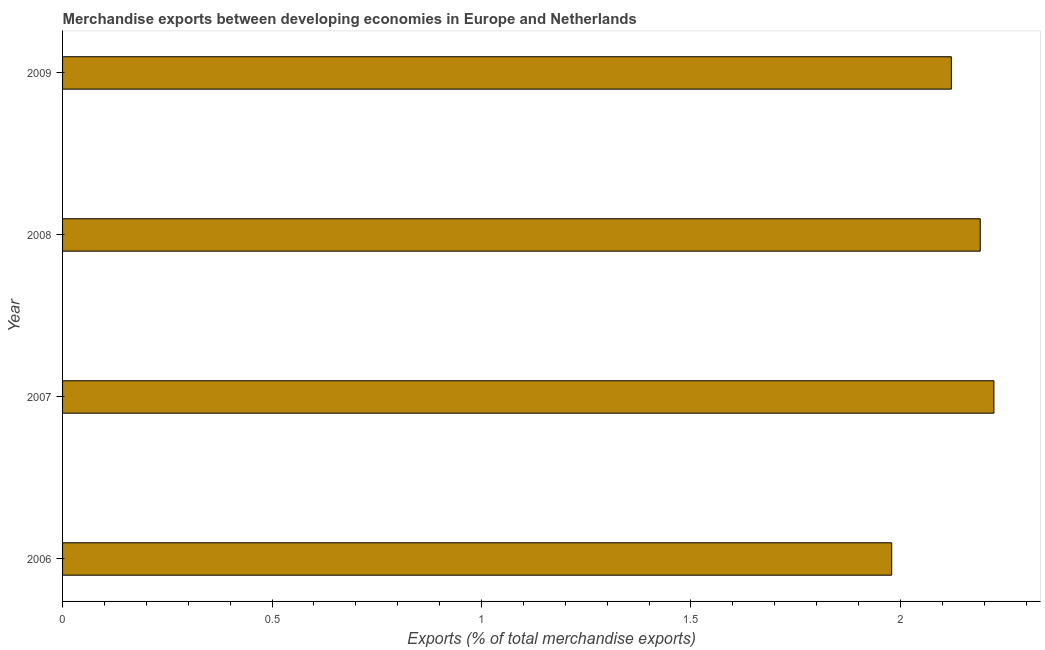Does the graph contain any zero values?
Your response must be concise. No. What is the title of the graph?
Keep it short and to the point. Merchandise exports between developing economies in Europe and Netherlands. What is the label or title of the X-axis?
Your answer should be very brief. Exports (% of total merchandise exports). What is the label or title of the Y-axis?
Your answer should be very brief. Year. What is the merchandise exports in 2009?
Keep it short and to the point. 2.12. Across all years, what is the maximum merchandise exports?
Provide a short and direct response. 2.22. Across all years, what is the minimum merchandise exports?
Make the answer very short. 1.98. In which year was the merchandise exports maximum?
Keep it short and to the point. 2007. What is the sum of the merchandise exports?
Ensure brevity in your answer.  8.51. What is the difference between the merchandise exports in 2008 and 2009?
Ensure brevity in your answer.  0.07. What is the average merchandise exports per year?
Ensure brevity in your answer.  2.13. What is the median merchandise exports?
Provide a short and direct response. 2.16. Do a majority of the years between 2008 and 2009 (inclusive) have merchandise exports greater than 0.8 %?
Provide a short and direct response. Yes. Is the difference between the merchandise exports in 2007 and 2008 greater than the difference between any two years?
Your answer should be compact. No. What is the difference between the highest and the second highest merchandise exports?
Offer a terse response. 0.03. What is the difference between the highest and the lowest merchandise exports?
Ensure brevity in your answer.  0.24. In how many years, is the merchandise exports greater than the average merchandise exports taken over all years?
Your response must be concise. 2. What is the difference between two consecutive major ticks on the X-axis?
Provide a succinct answer. 0.5. What is the Exports (% of total merchandise exports) in 2006?
Offer a very short reply. 1.98. What is the Exports (% of total merchandise exports) in 2007?
Provide a succinct answer. 2.22. What is the Exports (% of total merchandise exports) of 2008?
Your answer should be compact. 2.19. What is the Exports (% of total merchandise exports) in 2009?
Your answer should be very brief. 2.12. What is the difference between the Exports (% of total merchandise exports) in 2006 and 2007?
Offer a terse response. -0.24. What is the difference between the Exports (% of total merchandise exports) in 2006 and 2008?
Provide a succinct answer. -0.21. What is the difference between the Exports (% of total merchandise exports) in 2006 and 2009?
Keep it short and to the point. -0.14. What is the difference between the Exports (% of total merchandise exports) in 2007 and 2008?
Give a very brief answer. 0.03. What is the difference between the Exports (% of total merchandise exports) in 2007 and 2009?
Make the answer very short. 0.1. What is the difference between the Exports (% of total merchandise exports) in 2008 and 2009?
Make the answer very short. 0.07. What is the ratio of the Exports (% of total merchandise exports) in 2006 to that in 2007?
Provide a succinct answer. 0.89. What is the ratio of the Exports (% of total merchandise exports) in 2006 to that in 2008?
Your answer should be compact. 0.9. What is the ratio of the Exports (% of total merchandise exports) in 2006 to that in 2009?
Your answer should be compact. 0.93. What is the ratio of the Exports (% of total merchandise exports) in 2007 to that in 2009?
Give a very brief answer. 1.05. What is the ratio of the Exports (% of total merchandise exports) in 2008 to that in 2009?
Offer a terse response. 1.03. 